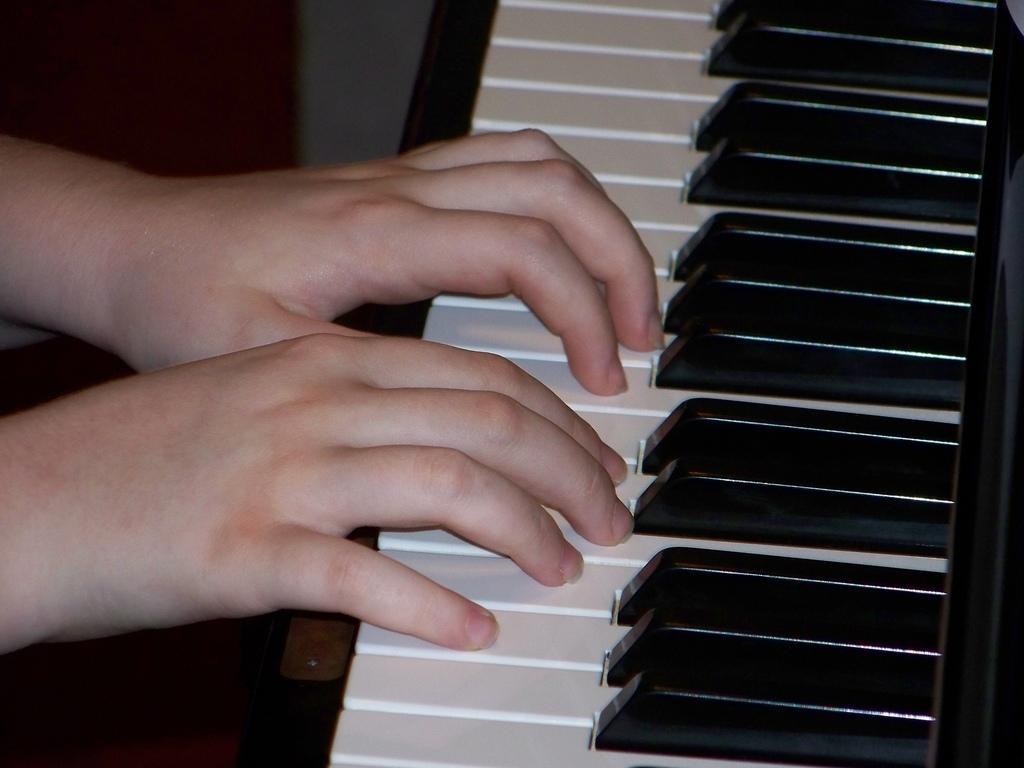Can you describe this image briefly? In this picture a person is playing piano. On the right side of the picture it is piano. On the left there are hands on the piano. 